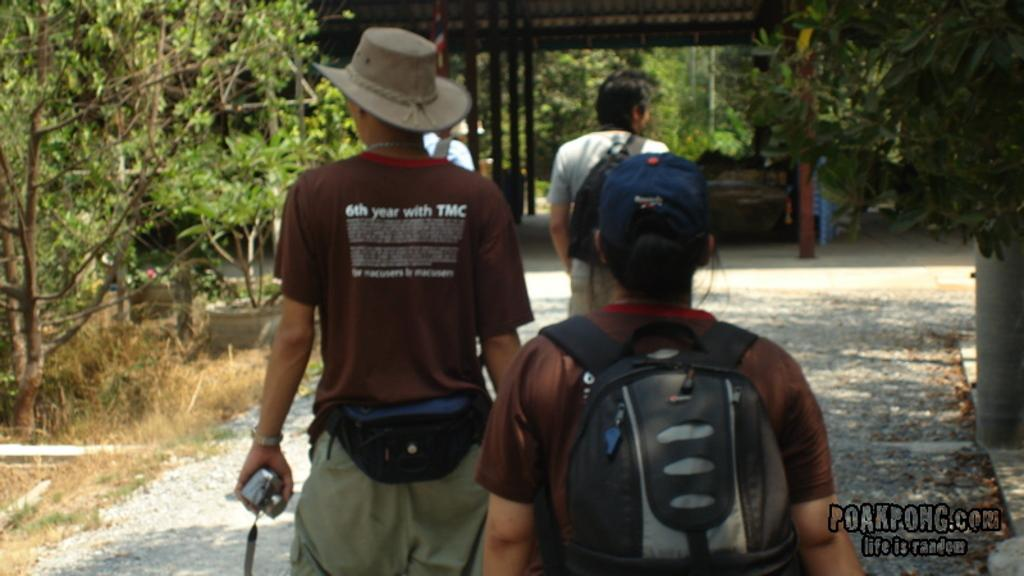<image>
Give a short and clear explanation of the subsequent image. A man hiking with a group of people is holding a camera and has the letters TMC on the back of his shirt. 